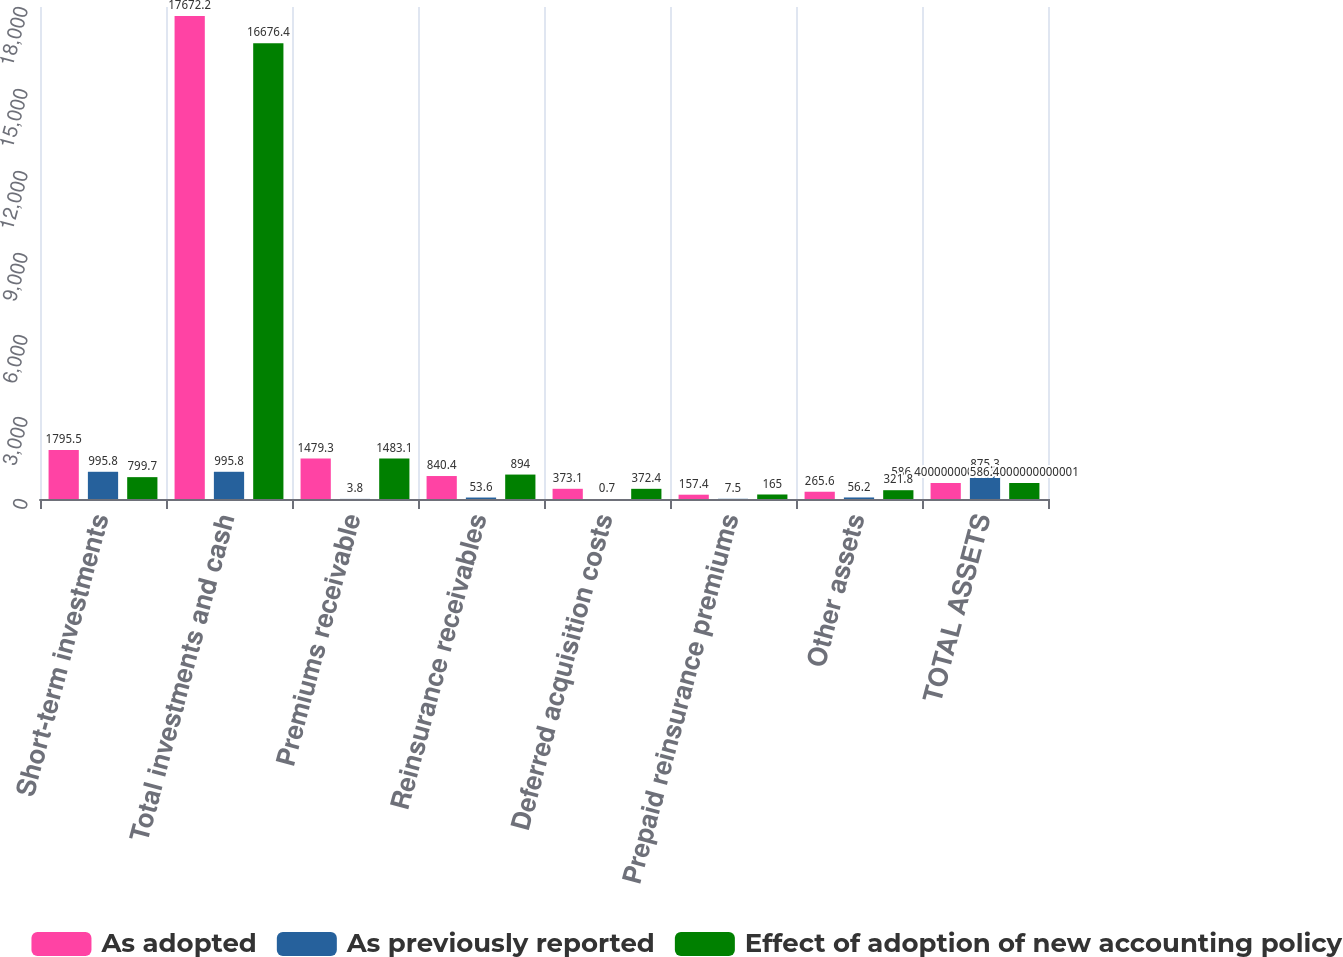Convert chart to OTSL. <chart><loc_0><loc_0><loc_500><loc_500><stacked_bar_chart><ecel><fcel>Short-term investments<fcel>Total investments and cash<fcel>Premiums receivable<fcel>Reinsurance receivables<fcel>Deferred acquisition costs<fcel>Prepaid reinsurance premiums<fcel>Other assets<fcel>TOTAL ASSETS<nl><fcel>As adopted<fcel>1795.5<fcel>17672.2<fcel>1479.3<fcel>840.4<fcel>373.1<fcel>157.4<fcel>265.6<fcel>586.4<nl><fcel>As previously reported<fcel>995.8<fcel>995.8<fcel>3.8<fcel>53.6<fcel>0.7<fcel>7.5<fcel>56.2<fcel>875.3<nl><fcel>Effect of adoption of new accounting policy<fcel>799.7<fcel>16676.4<fcel>1483.1<fcel>894<fcel>372.4<fcel>165<fcel>321.8<fcel>586.4<nl></chart> 